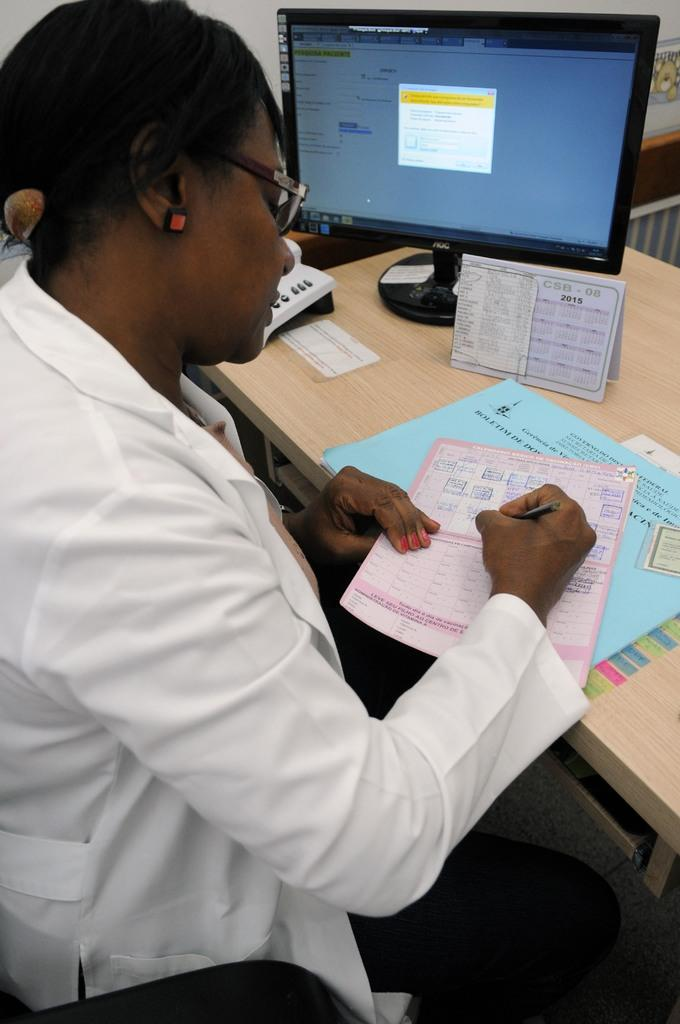<image>
Relay a brief, clear account of the picture shown. A desk with a 2015 calendar on it 